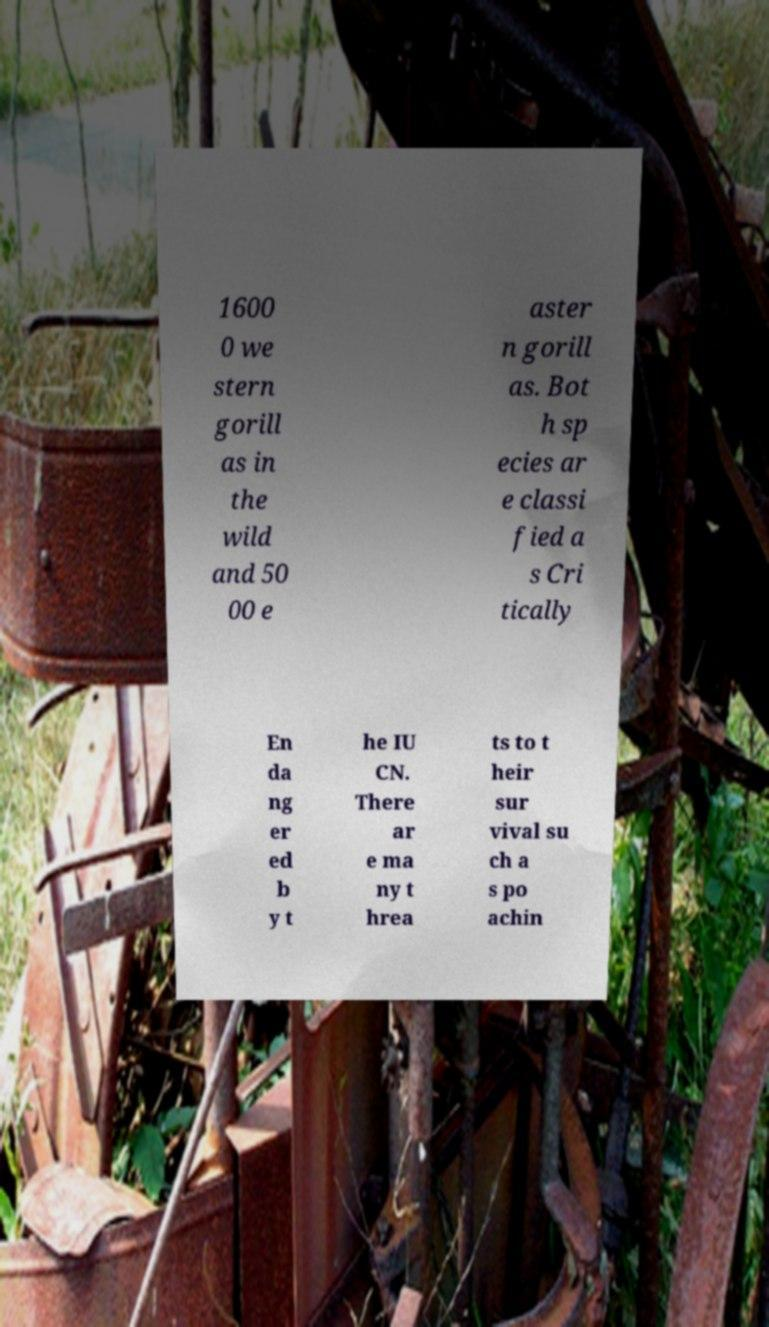Please read and relay the text visible in this image. What does it say? 1600 0 we stern gorill as in the wild and 50 00 e aster n gorill as. Bot h sp ecies ar e classi fied a s Cri tically En da ng er ed b y t he IU CN. There ar e ma ny t hrea ts to t heir sur vival su ch a s po achin 